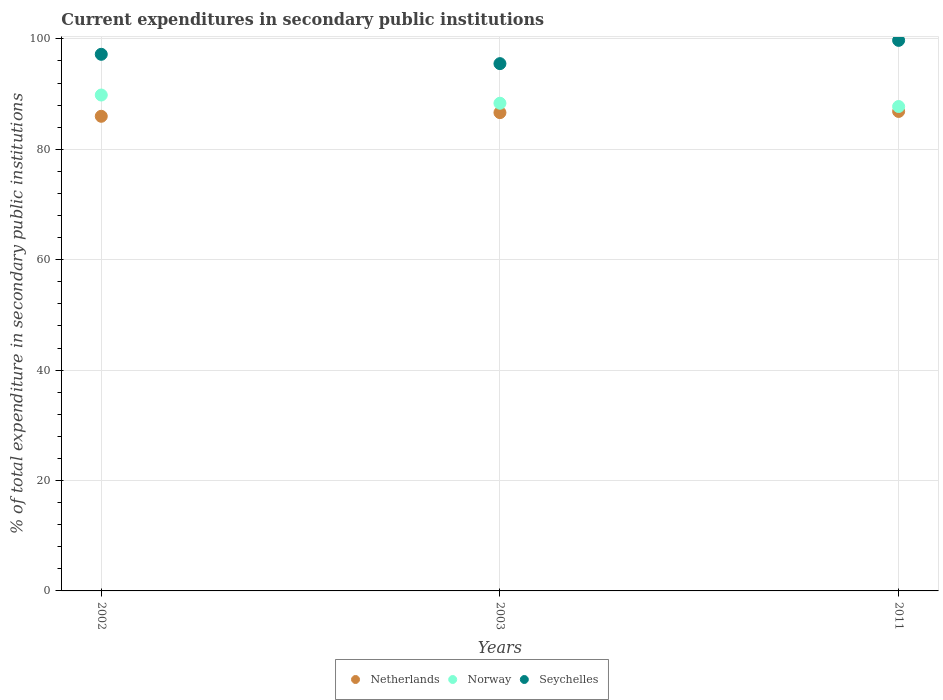How many different coloured dotlines are there?
Offer a very short reply. 3. Is the number of dotlines equal to the number of legend labels?
Your answer should be very brief. Yes. What is the current expenditures in secondary public institutions in Netherlands in 2003?
Your answer should be compact. 86.65. Across all years, what is the maximum current expenditures in secondary public institutions in Norway?
Give a very brief answer. 89.84. Across all years, what is the minimum current expenditures in secondary public institutions in Norway?
Offer a terse response. 87.75. In which year was the current expenditures in secondary public institutions in Netherlands minimum?
Offer a very short reply. 2002. What is the total current expenditures in secondary public institutions in Norway in the graph?
Offer a terse response. 265.93. What is the difference between the current expenditures in secondary public institutions in Netherlands in 2002 and that in 2003?
Give a very brief answer. -0.66. What is the difference between the current expenditures in secondary public institutions in Norway in 2011 and the current expenditures in secondary public institutions in Seychelles in 2003?
Offer a very short reply. -7.77. What is the average current expenditures in secondary public institutions in Seychelles per year?
Make the answer very short. 97.49. In the year 2002, what is the difference between the current expenditures in secondary public institutions in Seychelles and current expenditures in secondary public institutions in Netherlands?
Make the answer very short. 11.23. In how many years, is the current expenditures in secondary public institutions in Netherlands greater than 76 %?
Your answer should be compact. 3. What is the ratio of the current expenditures in secondary public institutions in Netherlands in 2002 to that in 2003?
Provide a succinct answer. 0.99. Is the current expenditures in secondary public institutions in Norway in 2002 less than that in 2011?
Offer a very short reply. No. What is the difference between the highest and the second highest current expenditures in secondary public institutions in Netherlands?
Offer a very short reply. 0.22. What is the difference between the highest and the lowest current expenditures in secondary public institutions in Norway?
Provide a succinct answer. 2.08. Does the current expenditures in secondary public institutions in Seychelles monotonically increase over the years?
Your response must be concise. No. Is the current expenditures in secondary public institutions in Seychelles strictly less than the current expenditures in secondary public institutions in Norway over the years?
Keep it short and to the point. No. How many dotlines are there?
Your answer should be very brief. 3. How many years are there in the graph?
Your answer should be very brief. 3. What is the difference between two consecutive major ticks on the Y-axis?
Your answer should be compact. 20. Are the values on the major ticks of Y-axis written in scientific E-notation?
Give a very brief answer. No. Does the graph contain any zero values?
Keep it short and to the point. No. What is the title of the graph?
Keep it short and to the point. Current expenditures in secondary public institutions. What is the label or title of the Y-axis?
Provide a succinct answer. % of total expenditure in secondary public institutions. What is the % of total expenditure in secondary public institutions in Netherlands in 2002?
Give a very brief answer. 85.98. What is the % of total expenditure in secondary public institutions of Norway in 2002?
Make the answer very short. 89.84. What is the % of total expenditure in secondary public institutions of Seychelles in 2002?
Your response must be concise. 97.21. What is the % of total expenditure in secondary public institutions in Netherlands in 2003?
Keep it short and to the point. 86.65. What is the % of total expenditure in secondary public institutions in Norway in 2003?
Provide a succinct answer. 88.35. What is the % of total expenditure in secondary public institutions in Seychelles in 2003?
Your answer should be compact. 95.52. What is the % of total expenditure in secondary public institutions in Netherlands in 2011?
Keep it short and to the point. 86.86. What is the % of total expenditure in secondary public institutions in Norway in 2011?
Offer a terse response. 87.75. What is the % of total expenditure in secondary public institutions of Seychelles in 2011?
Offer a terse response. 99.74. Across all years, what is the maximum % of total expenditure in secondary public institutions in Netherlands?
Provide a short and direct response. 86.86. Across all years, what is the maximum % of total expenditure in secondary public institutions of Norway?
Offer a very short reply. 89.84. Across all years, what is the maximum % of total expenditure in secondary public institutions in Seychelles?
Keep it short and to the point. 99.74. Across all years, what is the minimum % of total expenditure in secondary public institutions of Netherlands?
Your answer should be compact. 85.98. Across all years, what is the minimum % of total expenditure in secondary public institutions in Norway?
Ensure brevity in your answer.  87.75. Across all years, what is the minimum % of total expenditure in secondary public institutions of Seychelles?
Your answer should be very brief. 95.52. What is the total % of total expenditure in secondary public institutions of Netherlands in the graph?
Offer a terse response. 259.49. What is the total % of total expenditure in secondary public institutions in Norway in the graph?
Keep it short and to the point. 265.93. What is the total % of total expenditure in secondary public institutions of Seychelles in the graph?
Keep it short and to the point. 292.47. What is the difference between the % of total expenditure in secondary public institutions of Netherlands in 2002 and that in 2003?
Your response must be concise. -0.66. What is the difference between the % of total expenditure in secondary public institutions in Norway in 2002 and that in 2003?
Offer a terse response. 1.49. What is the difference between the % of total expenditure in secondary public institutions of Seychelles in 2002 and that in 2003?
Your answer should be compact. 1.69. What is the difference between the % of total expenditure in secondary public institutions of Netherlands in 2002 and that in 2011?
Your response must be concise. -0.88. What is the difference between the % of total expenditure in secondary public institutions in Norway in 2002 and that in 2011?
Provide a succinct answer. 2.08. What is the difference between the % of total expenditure in secondary public institutions in Seychelles in 2002 and that in 2011?
Provide a short and direct response. -2.52. What is the difference between the % of total expenditure in secondary public institutions in Netherlands in 2003 and that in 2011?
Ensure brevity in your answer.  -0.22. What is the difference between the % of total expenditure in secondary public institutions of Norway in 2003 and that in 2011?
Ensure brevity in your answer.  0.59. What is the difference between the % of total expenditure in secondary public institutions in Seychelles in 2003 and that in 2011?
Provide a succinct answer. -4.21. What is the difference between the % of total expenditure in secondary public institutions of Netherlands in 2002 and the % of total expenditure in secondary public institutions of Norway in 2003?
Keep it short and to the point. -2.36. What is the difference between the % of total expenditure in secondary public institutions of Netherlands in 2002 and the % of total expenditure in secondary public institutions of Seychelles in 2003?
Provide a short and direct response. -9.54. What is the difference between the % of total expenditure in secondary public institutions of Norway in 2002 and the % of total expenditure in secondary public institutions of Seychelles in 2003?
Offer a very short reply. -5.69. What is the difference between the % of total expenditure in secondary public institutions in Netherlands in 2002 and the % of total expenditure in secondary public institutions in Norway in 2011?
Give a very brief answer. -1.77. What is the difference between the % of total expenditure in secondary public institutions in Netherlands in 2002 and the % of total expenditure in secondary public institutions in Seychelles in 2011?
Give a very brief answer. -13.75. What is the difference between the % of total expenditure in secondary public institutions of Norway in 2002 and the % of total expenditure in secondary public institutions of Seychelles in 2011?
Provide a short and direct response. -9.9. What is the difference between the % of total expenditure in secondary public institutions in Netherlands in 2003 and the % of total expenditure in secondary public institutions in Norway in 2011?
Offer a very short reply. -1.11. What is the difference between the % of total expenditure in secondary public institutions of Netherlands in 2003 and the % of total expenditure in secondary public institutions of Seychelles in 2011?
Offer a very short reply. -13.09. What is the difference between the % of total expenditure in secondary public institutions of Norway in 2003 and the % of total expenditure in secondary public institutions of Seychelles in 2011?
Your response must be concise. -11.39. What is the average % of total expenditure in secondary public institutions of Netherlands per year?
Provide a short and direct response. 86.5. What is the average % of total expenditure in secondary public institutions in Norway per year?
Your answer should be very brief. 88.64. What is the average % of total expenditure in secondary public institutions of Seychelles per year?
Offer a very short reply. 97.49. In the year 2002, what is the difference between the % of total expenditure in secondary public institutions in Netherlands and % of total expenditure in secondary public institutions in Norway?
Ensure brevity in your answer.  -3.85. In the year 2002, what is the difference between the % of total expenditure in secondary public institutions of Netherlands and % of total expenditure in secondary public institutions of Seychelles?
Keep it short and to the point. -11.23. In the year 2002, what is the difference between the % of total expenditure in secondary public institutions in Norway and % of total expenditure in secondary public institutions in Seychelles?
Keep it short and to the point. -7.38. In the year 2003, what is the difference between the % of total expenditure in secondary public institutions of Netherlands and % of total expenditure in secondary public institutions of Norway?
Keep it short and to the point. -1.7. In the year 2003, what is the difference between the % of total expenditure in secondary public institutions in Netherlands and % of total expenditure in secondary public institutions in Seychelles?
Provide a short and direct response. -8.88. In the year 2003, what is the difference between the % of total expenditure in secondary public institutions of Norway and % of total expenditure in secondary public institutions of Seychelles?
Make the answer very short. -7.18. In the year 2011, what is the difference between the % of total expenditure in secondary public institutions in Netherlands and % of total expenditure in secondary public institutions in Norway?
Your response must be concise. -0.89. In the year 2011, what is the difference between the % of total expenditure in secondary public institutions in Netherlands and % of total expenditure in secondary public institutions in Seychelles?
Give a very brief answer. -12.87. In the year 2011, what is the difference between the % of total expenditure in secondary public institutions of Norway and % of total expenditure in secondary public institutions of Seychelles?
Your answer should be very brief. -11.98. What is the ratio of the % of total expenditure in secondary public institutions in Norway in 2002 to that in 2003?
Offer a very short reply. 1.02. What is the ratio of the % of total expenditure in secondary public institutions in Seychelles in 2002 to that in 2003?
Your response must be concise. 1.02. What is the ratio of the % of total expenditure in secondary public institutions of Netherlands in 2002 to that in 2011?
Ensure brevity in your answer.  0.99. What is the ratio of the % of total expenditure in secondary public institutions of Norway in 2002 to that in 2011?
Make the answer very short. 1.02. What is the ratio of the % of total expenditure in secondary public institutions in Seychelles in 2002 to that in 2011?
Give a very brief answer. 0.97. What is the ratio of the % of total expenditure in secondary public institutions in Norway in 2003 to that in 2011?
Make the answer very short. 1.01. What is the ratio of the % of total expenditure in secondary public institutions in Seychelles in 2003 to that in 2011?
Provide a succinct answer. 0.96. What is the difference between the highest and the second highest % of total expenditure in secondary public institutions of Netherlands?
Provide a short and direct response. 0.22. What is the difference between the highest and the second highest % of total expenditure in secondary public institutions in Norway?
Give a very brief answer. 1.49. What is the difference between the highest and the second highest % of total expenditure in secondary public institutions in Seychelles?
Your response must be concise. 2.52. What is the difference between the highest and the lowest % of total expenditure in secondary public institutions of Netherlands?
Make the answer very short. 0.88. What is the difference between the highest and the lowest % of total expenditure in secondary public institutions of Norway?
Provide a succinct answer. 2.08. What is the difference between the highest and the lowest % of total expenditure in secondary public institutions in Seychelles?
Offer a very short reply. 4.21. 